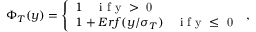Convert formula to latex. <formula><loc_0><loc_0><loc_500><loc_500>\Phi _ { T } ( y ) = \left \{ \begin{array} { l l } { 1 \quad i f y > 0 } \\ { 1 + E r f ( y / \sigma _ { T } ) \quad i f y \leq 0 } \end{array} ,</formula> 